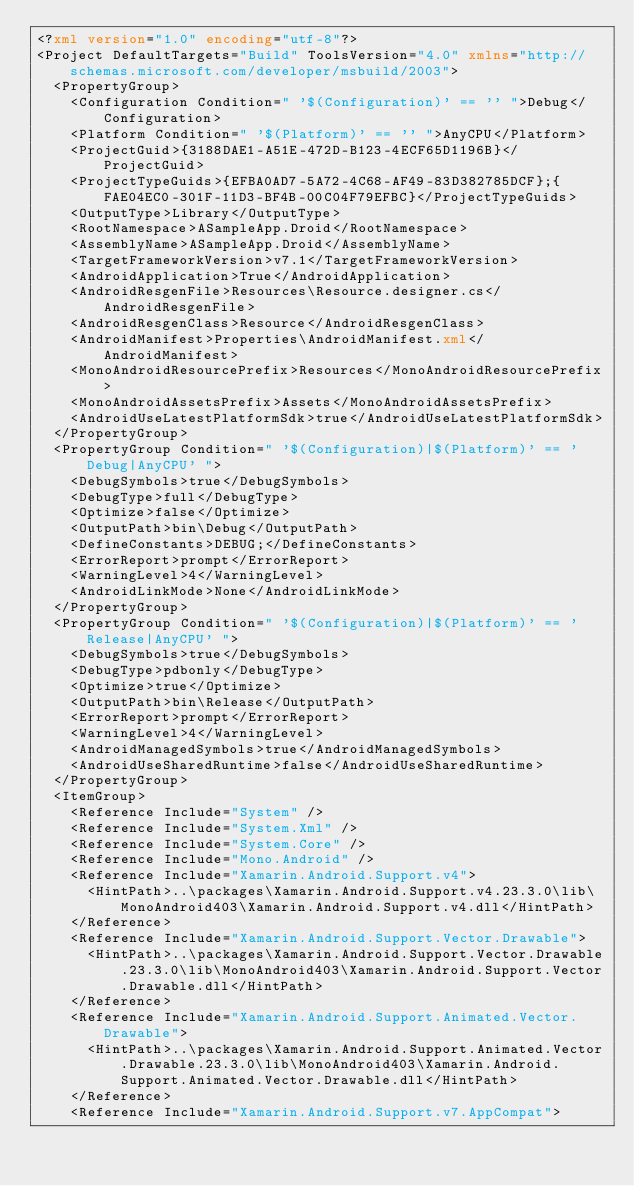<code> <loc_0><loc_0><loc_500><loc_500><_XML_><?xml version="1.0" encoding="utf-8"?>
<Project DefaultTargets="Build" ToolsVersion="4.0" xmlns="http://schemas.microsoft.com/developer/msbuild/2003">
  <PropertyGroup>
    <Configuration Condition=" '$(Configuration)' == '' ">Debug</Configuration>
    <Platform Condition=" '$(Platform)' == '' ">AnyCPU</Platform>
    <ProjectGuid>{3188DAE1-A51E-472D-B123-4ECF65D1196B}</ProjectGuid>
    <ProjectTypeGuids>{EFBA0AD7-5A72-4C68-AF49-83D382785DCF};{FAE04EC0-301F-11D3-BF4B-00C04F79EFBC}</ProjectTypeGuids>
    <OutputType>Library</OutputType>
    <RootNamespace>ASampleApp.Droid</RootNamespace>
    <AssemblyName>ASampleApp.Droid</AssemblyName>
    <TargetFrameworkVersion>v7.1</TargetFrameworkVersion>
    <AndroidApplication>True</AndroidApplication>
    <AndroidResgenFile>Resources\Resource.designer.cs</AndroidResgenFile>
    <AndroidResgenClass>Resource</AndroidResgenClass>
    <AndroidManifest>Properties\AndroidManifest.xml</AndroidManifest>
    <MonoAndroidResourcePrefix>Resources</MonoAndroidResourcePrefix>
    <MonoAndroidAssetsPrefix>Assets</MonoAndroidAssetsPrefix>
    <AndroidUseLatestPlatformSdk>true</AndroidUseLatestPlatformSdk>
  </PropertyGroup>
  <PropertyGroup Condition=" '$(Configuration)|$(Platform)' == 'Debug|AnyCPU' ">
    <DebugSymbols>true</DebugSymbols>
    <DebugType>full</DebugType>
    <Optimize>false</Optimize>
    <OutputPath>bin\Debug</OutputPath>
    <DefineConstants>DEBUG;</DefineConstants>
    <ErrorReport>prompt</ErrorReport>
    <WarningLevel>4</WarningLevel>
    <AndroidLinkMode>None</AndroidLinkMode>
  </PropertyGroup>
  <PropertyGroup Condition=" '$(Configuration)|$(Platform)' == 'Release|AnyCPU' ">
    <DebugSymbols>true</DebugSymbols>
    <DebugType>pdbonly</DebugType>
    <Optimize>true</Optimize>
    <OutputPath>bin\Release</OutputPath>
    <ErrorReport>prompt</ErrorReport>
    <WarningLevel>4</WarningLevel>
    <AndroidManagedSymbols>true</AndroidManagedSymbols>
    <AndroidUseSharedRuntime>false</AndroidUseSharedRuntime>
  </PropertyGroup>
  <ItemGroup>
    <Reference Include="System" />
    <Reference Include="System.Xml" />
    <Reference Include="System.Core" />
    <Reference Include="Mono.Android" />
    <Reference Include="Xamarin.Android.Support.v4">
      <HintPath>..\packages\Xamarin.Android.Support.v4.23.3.0\lib\MonoAndroid403\Xamarin.Android.Support.v4.dll</HintPath>
    </Reference>
    <Reference Include="Xamarin.Android.Support.Vector.Drawable">
      <HintPath>..\packages\Xamarin.Android.Support.Vector.Drawable.23.3.0\lib\MonoAndroid403\Xamarin.Android.Support.Vector.Drawable.dll</HintPath>
    </Reference>
    <Reference Include="Xamarin.Android.Support.Animated.Vector.Drawable">
      <HintPath>..\packages\Xamarin.Android.Support.Animated.Vector.Drawable.23.3.0\lib\MonoAndroid403\Xamarin.Android.Support.Animated.Vector.Drawable.dll</HintPath>
    </Reference>
    <Reference Include="Xamarin.Android.Support.v7.AppCompat"></code> 